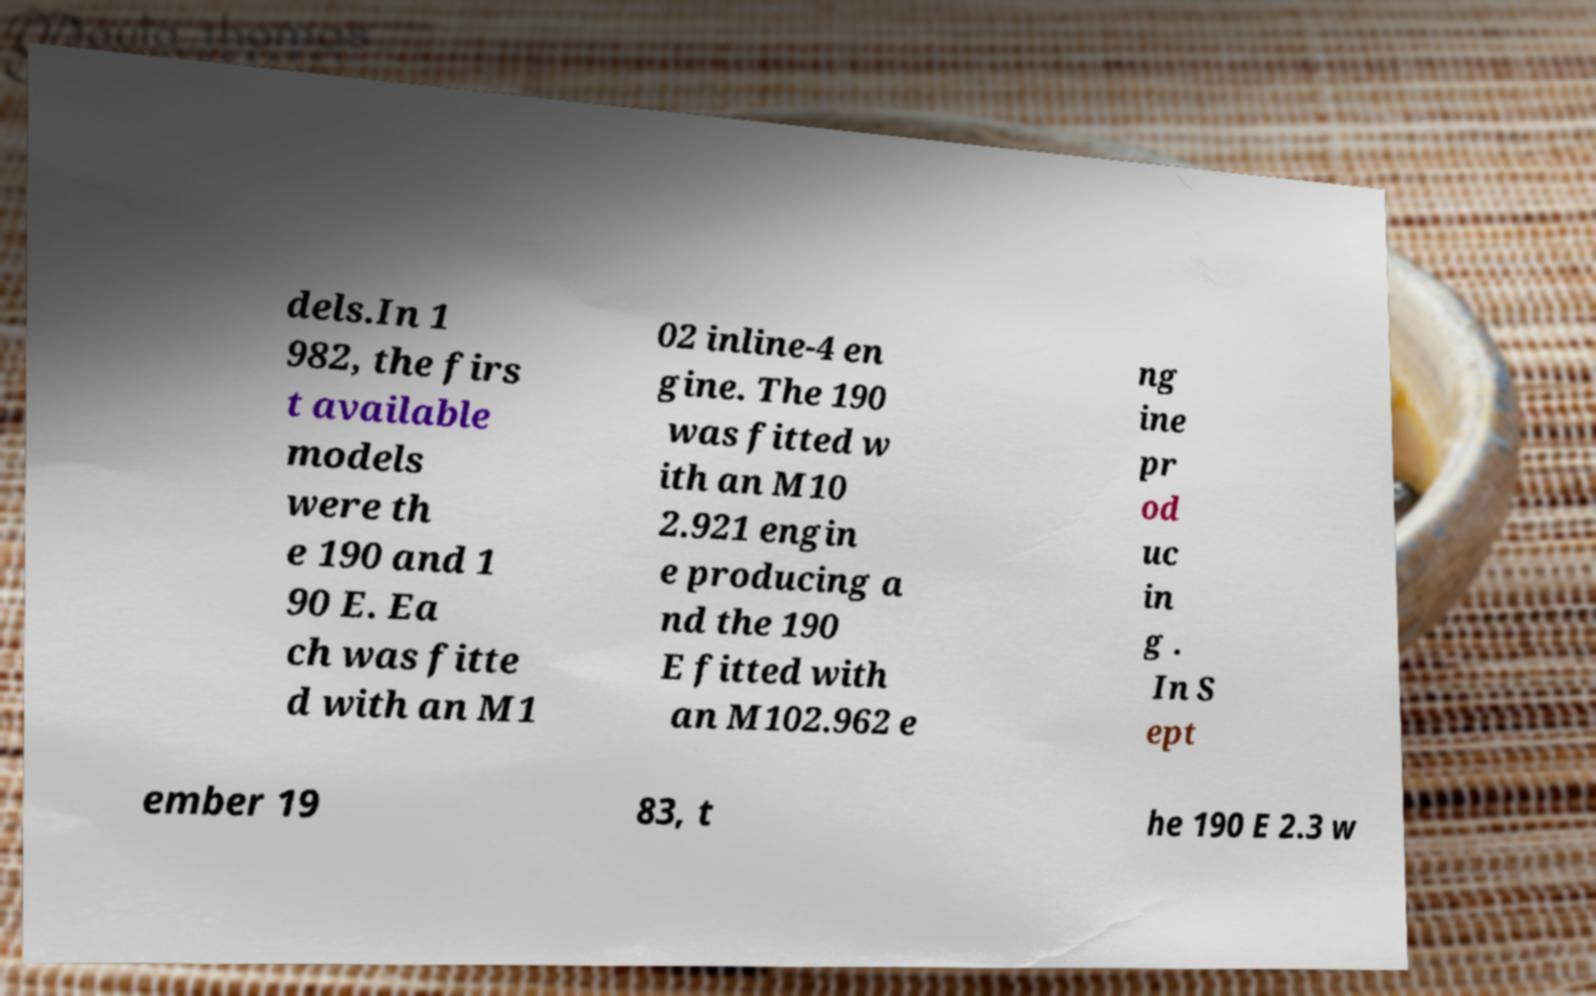Can you accurately transcribe the text from the provided image for me? dels.In 1 982, the firs t available models were th e 190 and 1 90 E. Ea ch was fitte d with an M1 02 inline-4 en gine. The 190 was fitted w ith an M10 2.921 engin e producing a nd the 190 E fitted with an M102.962 e ng ine pr od uc in g . In S ept ember 19 83, t he 190 E 2.3 w 